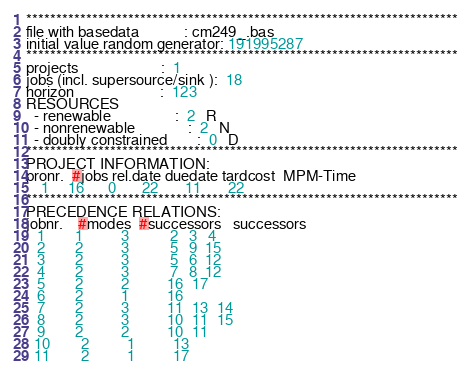<code> <loc_0><loc_0><loc_500><loc_500><_ObjectiveC_>************************************************************************
file with basedata            : cm249_.bas
initial value random generator: 191995287
************************************************************************
projects                      :  1
jobs (incl. supersource/sink ):  18
horizon                       :  123
RESOURCES
  - renewable                 :  2   R
  - nonrenewable              :  2   N
  - doubly constrained        :  0   D
************************************************************************
PROJECT INFORMATION:
pronr.  #jobs rel.date duedate tardcost  MPM-Time
    1     16      0       22       11       22
************************************************************************
PRECEDENCE RELATIONS:
jobnr.    #modes  #successors   successors
   1        1          3           2   3   4
   2        2          3           5   9  15
   3        2          3           5   6  12
   4        2          3           7   8  12
   5        2          2          16  17
   6        2          1          16
   7        2          3          11  13  14
   8        2          3          10  11  15
   9        2          2          10  11
  10        2          1          13
  11        2          1          17</code> 